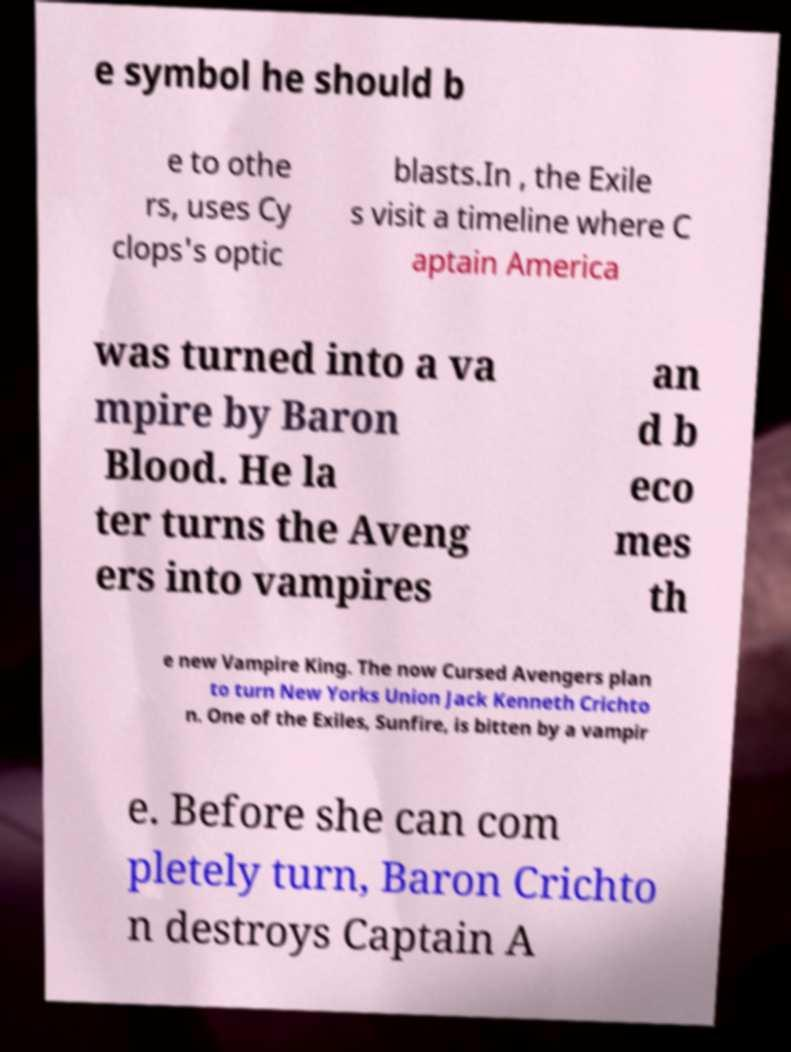I need the written content from this picture converted into text. Can you do that? e symbol he should b e to othe rs, uses Cy clops's optic blasts.In , the Exile s visit a timeline where C aptain America was turned into a va mpire by Baron Blood. He la ter turns the Aveng ers into vampires an d b eco mes th e new Vampire King. The now Cursed Avengers plan to turn New Yorks Union Jack Kenneth Crichto n. One of the Exiles, Sunfire, is bitten by a vampir e. Before she can com pletely turn, Baron Crichto n destroys Captain A 